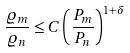<formula> <loc_0><loc_0><loc_500><loc_500>\frac { \varrho _ { m } } { \varrho _ { n } } \leq C \left ( \frac { P _ { m } } { P _ { n } } \right ) ^ { 1 + \delta }</formula> 